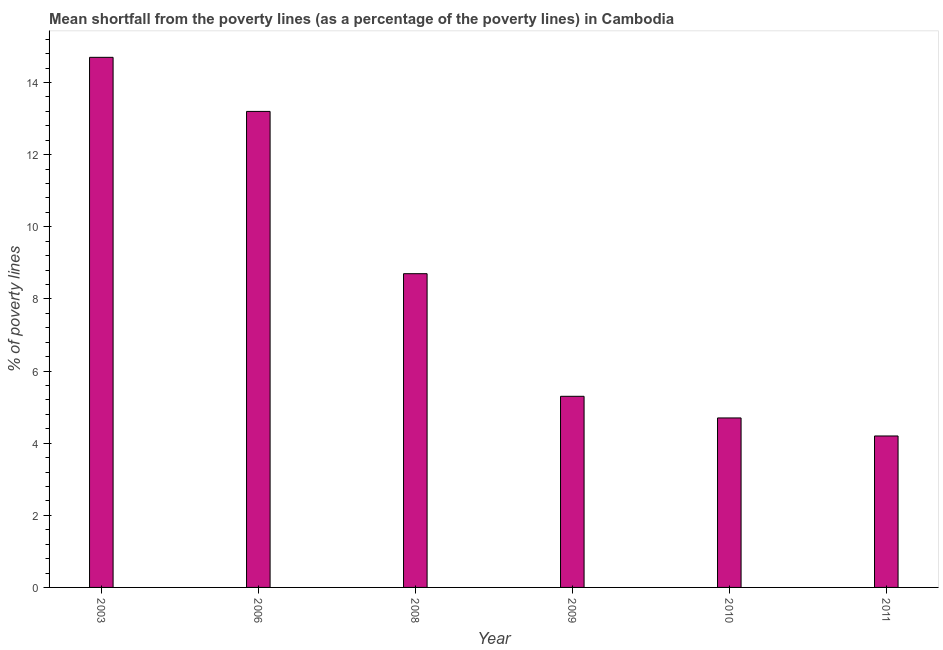Does the graph contain any zero values?
Offer a very short reply. No. Does the graph contain grids?
Your response must be concise. No. What is the title of the graph?
Offer a very short reply. Mean shortfall from the poverty lines (as a percentage of the poverty lines) in Cambodia. What is the label or title of the X-axis?
Keep it short and to the point. Year. What is the label or title of the Y-axis?
Your response must be concise. % of poverty lines. What is the poverty gap at national poverty lines in 2006?
Keep it short and to the point. 13.2. Across all years, what is the maximum poverty gap at national poverty lines?
Offer a terse response. 14.7. Across all years, what is the minimum poverty gap at national poverty lines?
Your answer should be compact. 4.2. In which year was the poverty gap at national poverty lines maximum?
Your response must be concise. 2003. What is the sum of the poverty gap at national poverty lines?
Your response must be concise. 50.8. What is the difference between the poverty gap at national poverty lines in 2006 and 2010?
Offer a terse response. 8.5. What is the average poverty gap at national poverty lines per year?
Provide a succinct answer. 8.47. What is the ratio of the poverty gap at national poverty lines in 2003 to that in 2009?
Keep it short and to the point. 2.77. What is the difference between the highest and the lowest poverty gap at national poverty lines?
Your answer should be very brief. 10.5. In how many years, is the poverty gap at national poverty lines greater than the average poverty gap at national poverty lines taken over all years?
Your answer should be compact. 3. How many years are there in the graph?
Offer a terse response. 6. What is the difference between two consecutive major ticks on the Y-axis?
Your response must be concise. 2. Are the values on the major ticks of Y-axis written in scientific E-notation?
Keep it short and to the point. No. What is the % of poverty lines of 2006?
Ensure brevity in your answer.  13.2. What is the % of poverty lines of 2009?
Offer a terse response. 5.3. What is the % of poverty lines of 2011?
Provide a short and direct response. 4.2. What is the difference between the % of poverty lines in 2003 and 2010?
Your response must be concise. 10. What is the difference between the % of poverty lines in 2006 and 2008?
Provide a succinct answer. 4.5. What is the difference between the % of poverty lines in 2006 and 2009?
Provide a succinct answer. 7.9. What is the difference between the % of poverty lines in 2008 and 2009?
Provide a short and direct response. 3.4. What is the difference between the % of poverty lines in 2008 and 2010?
Keep it short and to the point. 4. What is the difference between the % of poverty lines in 2008 and 2011?
Offer a terse response. 4.5. What is the difference between the % of poverty lines in 2009 and 2010?
Ensure brevity in your answer.  0.6. What is the difference between the % of poverty lines in 2010 and 2011?
Keep it short and to the point. 0.5. What is the ratio of the % of poverty lines in 2003 to that in 2006?
Make the answer very short. 1.11. What is the ratio of the % of poverty lines in 2003 to that in 2008?
Make the answer very short. 1.69. What is the ratio of the % of poverty lines in 2003 to that in 2009?
Your response must be concise. 2.77. What is the ratio of the % of poverty lines in 2003 to that in 2010?
Your answer should be very brief. 3.13. What is the ratio of the % of poverty lines in 2006 to that in 2008?
Your answer should be very brief. 1.52. What is the ratio of the % of poverty lines in 2006 to that in 2009?
Offer a terse response. 2.49. What is the ratio of the % of poverty lines in 2006 to that in 2010?
Provide a succinct answer. 2.81. What is the ratio of the % of poverty lines in 2006 to that in 2011?
Make the answer very short. 3.14. What is the ratio of the % of poverty lines in 2008 to that in 2009?
Offer a very short reply. 1.64. What is the ratio of the % of poverty lines in 2008 to that in 2010?
Your response must be concise. 1.85. What is the ratio of the % of poverty lines in 2008 to that in 2011?
Offer a terse response. 2.07. What is the ratio of the % of poverty lines in 2009 to that in 2010?
Offer a very short reply. 1.13. What is the ratio of the % of poverty lines in 2009 to that in 2011?
Provide a short and direct response. 1.26. What is the ratio of the % of poverty lines in 2010 to that in 2011?
Offer a very short reply. 1.12. 